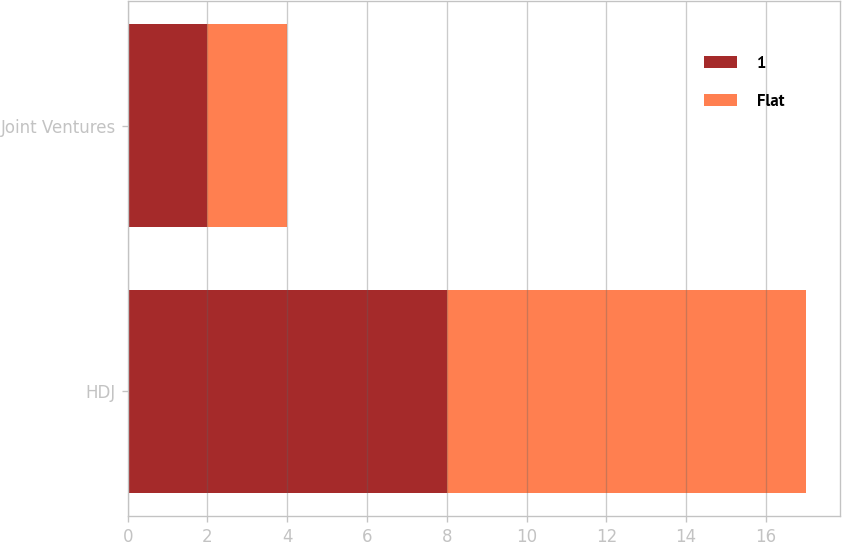Convert chart. <chart><loc_0><loc_0><loc_500><loc_500><stacked_bar_chart><ecel><fcel>HDJ<fcel>Joint Ventures<nl><fcel>1<fcel>8<fcel>2<nl><fcel>Flat<fcel>9<fcel>2<nl></chart> 